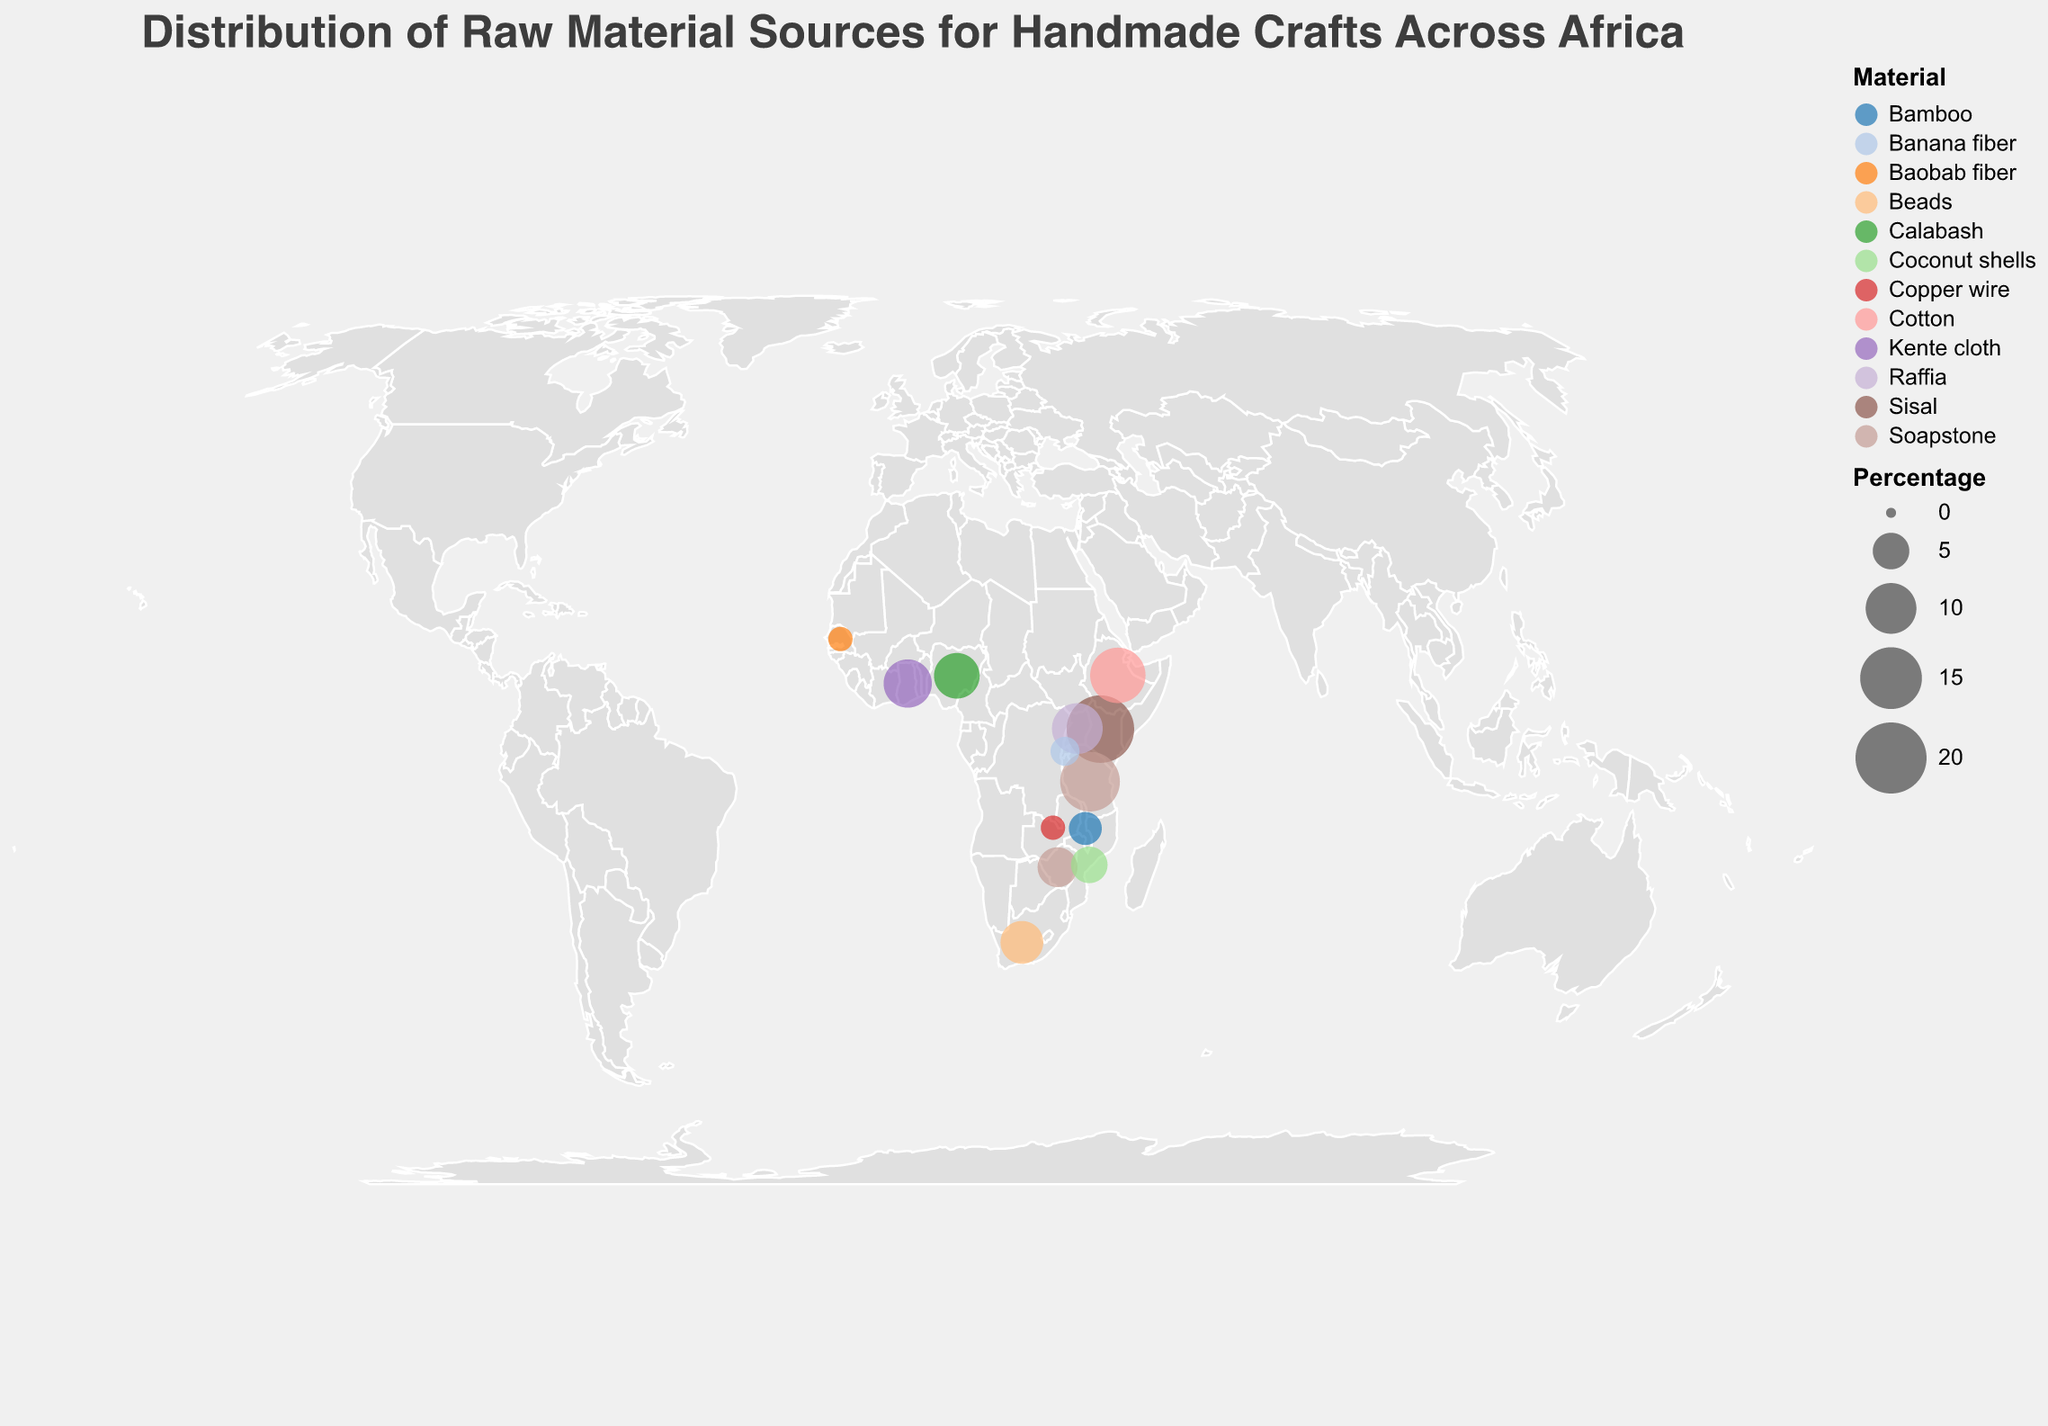What is the title of the figure? The title is displayed at the top of the plot and provides a summary of what the figure represents. In this case, the title specifies that the figure is about the distribution of raw material sources for handmade crafts across Africa.
Answer: Distribution of Raw Material Sources for Handmade Crafts Across Africa Which country has the highest percentage of raw material contribution? By looking at the size of the circles, we can identify the country with the largest circle, which corresponds to the highest percentage of raw material contribution.
Answer: Kenya How many countries contribute soapstone as a raw material? The colors of the circles represent different materials. By looking at the color legend and finding the color for soapstone, we can count the number of matching circles on the map.
Answer: 2 What is the combined percentage contribution of Ethiopia and Uganda? Adding the percentage contribution of each country gives us the combined contribution. For Ethiopia, it is 12%, and for Uganda, it is 10%. So, we calculate 12% + 10% = 22%.
Answer: 22% Which raw material is least represented in the figure? The size of the circles and the percentage values give us an idea of representation. By comparison, the smallest circle represents the lowest contribution. In this case, both copper wire and baobab fiber have the smallest circles with equal percentages.
Answer: Copper wire and Baobab fiber Which country contributes raffia, and what is their percentage? By locating the circle colored for raffia and checking the tooltip for that circle, we can identify the country and its percentage.
Answer: Uganda, 10% How does the percentage contribution of banana fiber compare to coconut shells? By referring to the size of the circles and the tooltip, we see that banana fiber has a 3% contribution, and coconut shells have a 5% contribution.
Answer: Coconut shells have a higher contribution than banana fiber What is the average percentage contribution of the materials listed? To find the average, we sum up all percentages and divide by the number of countries. (18+14+12+10+9+8+7+6+5+4+3+2+2)/13 = 8.23%
Answer: 8.23% Which country is located at the southernmost point on the map, and what material do they contribute? By checking the latitude values, the country with the most negative latitude is South Africa. Their contributed material is beads.
Answer: South Africa, Beads Which material has the closest percentage contribution between two countries, and what are those countries? By inspecting the percentage values for each material, we find that soapstone has percentages of 14% and 6% contributed by Tanzania and Zimbabwe respectively. However, looking closer, baobab fiber has equal contributions of 2% from Senegal and Zambia.
Answer: Baobab fiber, Senegal and Zambia 